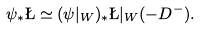Convert formula to latex. <formula><loc_0><loc_0><loc_500><loc_500>\psi _ { * } \L \simeq ( \psi | _ { W } ) _ { * } \L | _ { W } ( - D ^ { - } ) .</formula> 